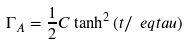<formula> <loc_0><loc_0><loc_500><loc_500>\Gamma _ { A } = \frac { 1 } { 2 } C \tanh ^ { 2 } \left ( t / \ e q t a u \right )</formula> 